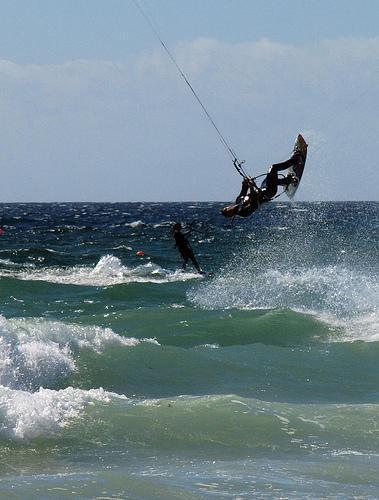How many people are in the photo?
Give a very brief answer. 2. 